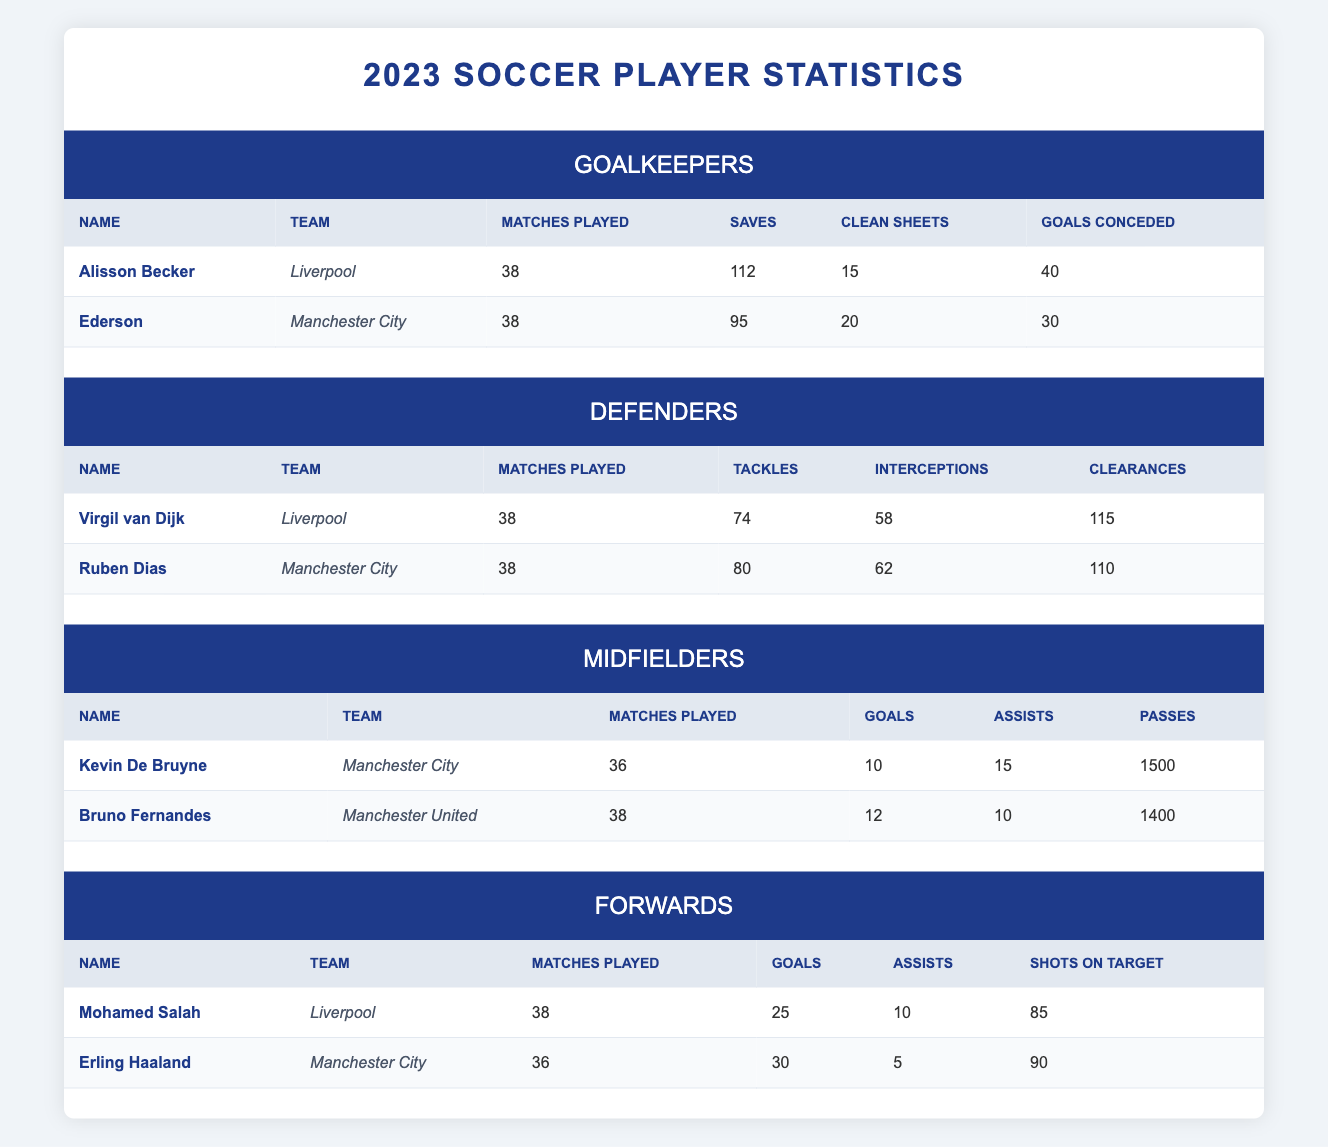What is the total number of clean sheets for all goalkeepers? Alisson Becker has 15 clean sheets, and Ederson has 20 clean sheets. Adding these gives 15 + 20 = 35 clean sheets in total.
Answer: 35 Which player scored the most goals among the forwards? Mohamed Salah scored 25 goals, while Erling Haaland scored 30 goals. Comparing the two, we see that Erling Haaland scored more.
Answer: Erling Haaland Did Bruno Fernandes play more matches than Kevin De Bruyne? Bruno Fernandes played 38 matches, and Kevin De Bruyne played 36 matches. Since 38 is greater than 36, Bruno Fernandes played more matches.
Answer: Yes What is the average number of goals scored by the midfielders? Kevin De Bruyne scored 10 goals, and Bruno Fernandes scored 12 goals. The total number of goals is 10 + 12 = 22, and there are 2 midfielders. Therefore, the average is 22 / 2 = 11.
Answer: 11 Who made more saves, Alisson Becker or Ederson? Alisson Becker made 112 saves, while Ederson made 95 saves. Comparing the two figures, Alisson Becker made significantly more saves.
Answer: Alisson Becker What is the difference in goals scored between Erling Haaland and Mohamed Salah? Erling Haaland scored 30 goals, while Mohamed Salah scored 25 goals. The difference is 30 - 25 = 5 goals.
Answer: 5 Which defender had the highest number of clearances? Virgil van Dijk had 115 clearances, and Ruben Dias had 110 clearances. Comparing both, Virgil van Dijk had the higher clearances at 115.
Answer: Virgil van Dijk Did both goalkeepers play the same number of matches? Both Alisson Becker and Ederson played 38 matches. Since the numbers are identical, they played the same number of matches.
Answer: Yes What is the total number of goals scored by all midfielders? Kevin De Bruyne scored 10 goals and Bruno Fernandes scored 12 goals. Summing these gives a total of 10 + 12 = 22 goals scored by all midfielders.
Answer: 22 Who had a higher number of interceptions, Ruben Dias or Virgil van Dijk? Ruben Dias had 62 interceptions, whereas Virgil van Dijk had 58 interceptions. Comparing these, Ruben Dias had more interceptions.
Answer: Ruben Dias 